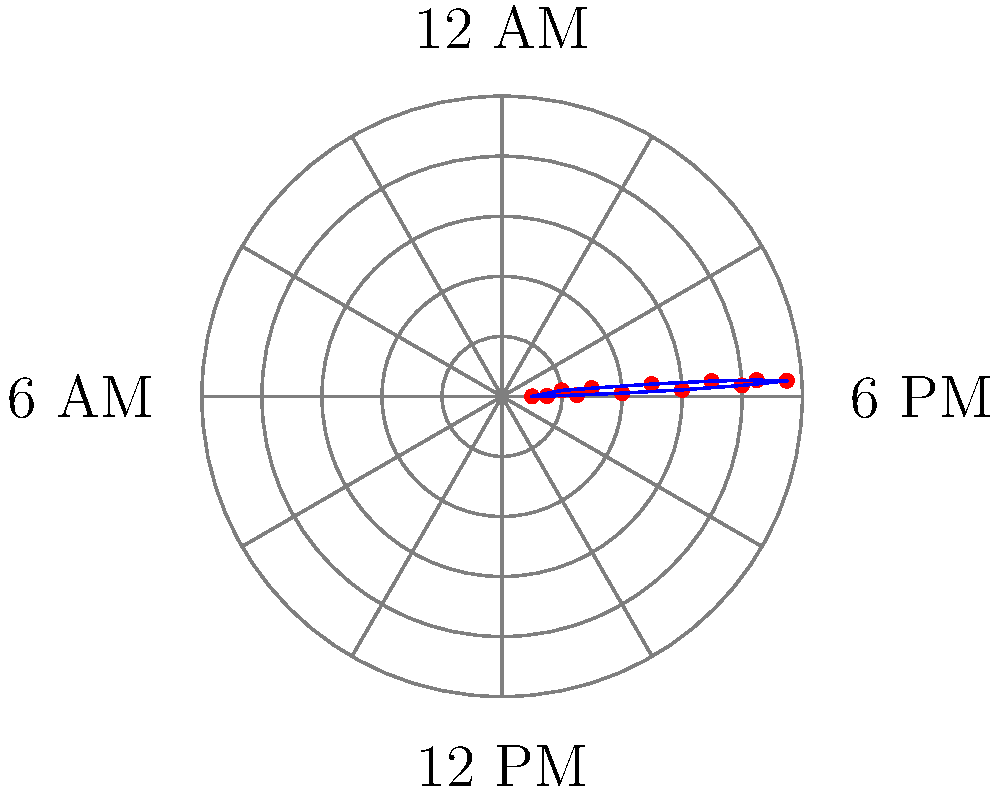As a computer systems analyst, you're monitoring network traffic volume over a 24-hour period. The data is plotted on a polar coordinate system, where the angle represents the time of day (with 0° corresponding to 12 AM, and increasing clockwise), and the radius represents the traffic volume. Based on the graph, at what time does the network traffic reach its peak? To determine the time of peak network traffic, we need to follow these steps:

1. Observe that the polar plot represents a 24-hour cycle, with the angle indicating the time of day.
2. The circumference of the plot is divided into 12 equal parts, each representing 2 hours.
3. The radius of the plot represents the traffic volume, with larger values indicating higher traffic.
4. Analyze the graph to find the point farthest from the center, which represents the highest traffic volume.
5. The peak appears to occur at the 7th division from the 12 AM position (0°), moving clockwise.
6. Each division represents 2 hours, so 7 divisions equate to 14 hours from 12 AM.
7. 14 hours after 12 AM is 2 PM (14:00).

Therefore, the network traffic reaches its peak at approximately 2 PM.
Answer: 2 PM 